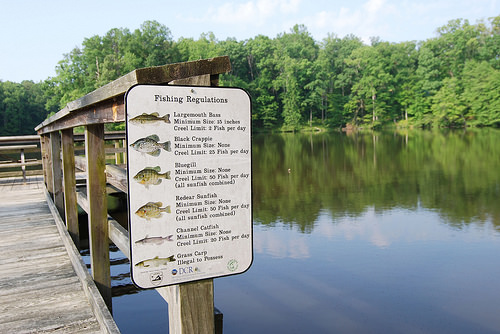<image>
Can you confirm if the fish is on the sign? Yes. Looking at the image, I can see the fish is positioned on top of the sign, with the sign providing support. 